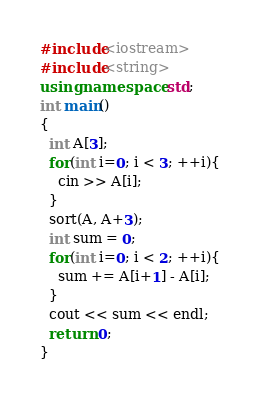<code> <loc_0><loc_0><loc_500><loc_500><_C++_>#include<iostream>
#include<string>
using namespace std;
int main()
{
  int A[3];
  for(int i=0; i < 3; ++i){
    cin >> A[i];
  }
  sort(A, A+3);
  int sum = 0;
  for(int i=0; i < 2; ++i){
    sum += A[i+1] - A[i];
  }
  cout << sum << endl;
  return 0;
}
</code> 